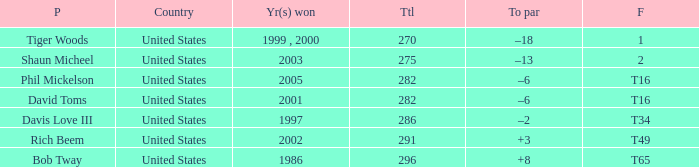In which year(s) did the person with a total greater than 286 win? 2002, 1986. 